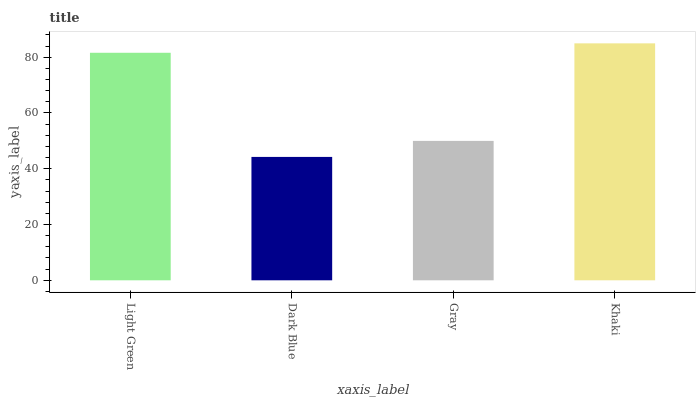Is Dark Blue the minimum?
Answer yes or no. Yes. Is Khaki the maximum?
Answer yes or no. Yes. Is Gray the minimum?
Answer yes or no. No. Is Gray the maximum?
Answer yes or no. No. Is Gray greater than Dark Blue?
Answer yes or no. Yes. Is Dark Blue less than Gray?
Answer yes or no. Yes. Is Dark Blue greater than Gray?
Answer yes or no. No. Is Gray less than Dark Blue?
Answer yes or no. No. Is Light Green the high median?
Answer yes or no. Yes. Is Gray the low median?
Answer yes or no. Yes. Is Dark Blue the high median?
Answer yes or no. No. Is Light Green the low median?
Answer yes or no. No. 